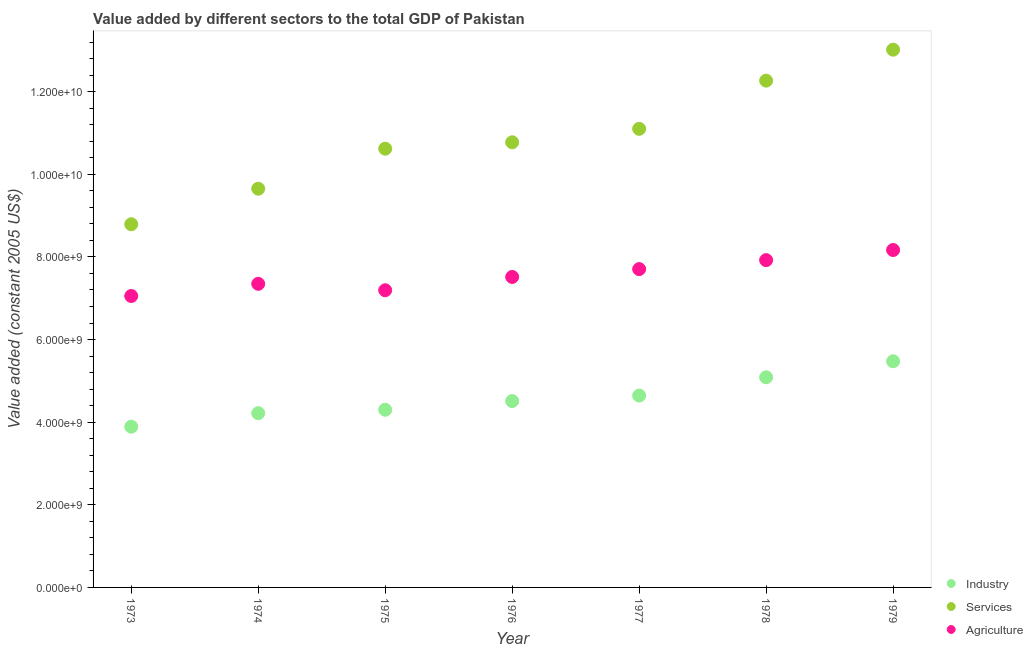What is the value added by industrial sector in 1978?
Make the answer very short. 5.09e+09. Across all years, what is the maximum value added by services?
Offer a terse response. 1.30e+1. Across all years, what is the minimum value added by agricultural sector?
Keep it short and to the point. 7.05e+09. In which year was the value added by agricultural sector maximum?
Provide a short and direct response. 1979. In which year was the value added by services minimum?
Offer a very short reply. 1973. What is the total value added by industrial sector in the graph?
Your answer should be compact. 3.21e+1. What is the difference between the value added by services in 1978 and that in 1979?
Your response must be concise. -7.49e+08. What is the difference between the value added by agricultural sector in 1975 and the value added by services in 1976?
Give a very brief answer. -3.58e+09. What is the average value added by agricultural sector per year?
Keep it short and to the point. 7.56e+09. In the year 1973, what is the difference between the value added by industrial sector and value added by services?
Offer a terse response. -4.90e+09. In how many years, is the value added by agricultural sector greater than 10000000000 US$?
Make the answer very short. 0. What is the ratio of the value added by industrial sector in 1974 to that in 1978?
Offer a very short reply. 0.83. Is the value added by agricultural sector in 1973 less than that in 1975?
Give a very brief answer. Yes. Is the difference between the value added by services in 1973 and 1975 greater than the difference between the value added by industrial sector in 1973 and 1975?
Provide a succinct answer. No. What is the difference between the highest and the second highest value added by services?
Your answer should be very brief. 7.49e+08. What is the difference between the highest and the lowest value added by agricultural sector?
Your response must be concise. 1.11e+09. In how many years, is the value added by services greater than the average value added by services taken over all years?
Your response must be concise. 3. Does the value added by services monotonically increase over the years?
Offer a terse response. Yes. Is the value added by services strictly less than the value added by industrial sector over the years?
Make the answer very short. No. How many dotlines are there?
Ensure brevity in your answer.  3. Does the graph contain any zero values?
Give a very brief answer. No. Does the graph contain grids?
Provide a short and direct response. No. What is the title of the graph?
Your answer should be compact. Value added by different sectors to the total GDP of Pakistan. What is the label or title of the Y-axis?
Your answer should be compact. Value added (constant 2005 US$). What is the Value added (constant 2005 US$) in Industry in 1973?
Your answer should be very brief. 3.89e+09. What is the Value added (constant 2005 US$) in Services in 1973?
Your answer should be compact. 8.79e+09. What is the Value added (constant 2005 US$) in Agriculture in 1973?
Your answer should be very brief. 7.05e+09. What is the Value added (constant 2005 US$) of Industry in 1974?
Your answer should be very brief. 4.22e+09. What is the Value added (constant 2005 US$) in Services in 1974?
Your response must be concise. 9.65e+09. What is the Value added (constant 2005 US$) in Agriculture in 1974?
Ensure brevity in your answer.  7.35e+09. What is the Value added (constant 2005 US$) of Industry in 1975?
Offer a very short reply. 4.30e+09. What is the Value added (constant 2005 US$) in Services in 1975?
Your response must be concise. 1.06e+1. What is the Value added (constant 2005 US$) of Agriculture in 1975?
Offer a very short reply. 7.19e+09. What is the Value added (constant 2005 US$) of Industry in 1976?
Give a very brief answer. 4.51e+09. What is the Value added (constant 2005 US$) in Services in 1976?
Give a very brief answer. 1.08e+1. What is the Value added (constant 2005 US$) of Agriculture in 1976?
Offer a very short reply. 7.52e+09. What is the Value added (constant 2005 US$) in Industry in 1977?
Your answer should be very brief. 4.64e+09. What is the Value added (constant 2005 US$) of Services in 1977?
Your response must be concise. 1.11e+1. What is the Value added (constant 2005 US$) in Agriculture in 1977?
Offer a very short reply. 7.71e+09. What is the Value added (constant 2005 US$) in Industry in 1978?
Your answer should be compact. 5.09e+09. What is the Value added (constant 2005 US$) in Services in 1978?
Keep it short and to the point. 1.23e+1. What is the Value added (constant 2005 US$) in Agriculture in 1978?
Your answer should be very brief. 7.92e+09. What is the Value added (constant 2005 US$) of Industry in 1979?
Give a very brief answer. 5.47e+09. What is the Value added (constant 2005 US$) of Services in 1979?
Provide a succinct answer. 1.30e+1. What is the Value added (constant 2005 US$) of Agriculture in 1979?
Your answer should be very brief. 8.17e+09. Across all years, what is the maximum Value added (constant 2005 US$) in Industry?
Your answer should be very brief. 5.47e+09. Across all years, what is the maximum Value added (constant 2005 US$) of Services?
Make the answer very short. 1.30e+1. Across all years, what is the maximum Value added (constant 2005 US$) of Agriculture?
Offer a very short reply. 8.17e+09. Across all years, what is the minimum Value added (constant 2005 US$) in Industry?
Ensure brevity in your answer.  3.89e+09. Across all years, what is the minimum Value added (constant 2005 US$) of Services?
Your answer should be compact. 8.79e+09. Across all years, what is the minimum Value added (constant 2005 US$) in Agriculture?
Keep it short and to the point. 7.05e+09. What is the total Value added (constant 2005 US$) in Industry in the graph?
Give a very brief answer. 3.21e+1. What is the total Value added (constant 2005 US$) in Services in the graph?
Provide a succinct answer. 7.62e+1. What is the total Value added (constant 2005 US$) of Agriculture in the graph?
Your answer should be very brief. 5.29e+1. What is the difference between the Value added (constant 2005 US$) of Industry in 1973 and that in 1974?
Your answer should be compact. -3.27e+08. What is the difference between the Value added (constant 2005 US$) of Services in 1973 and that in 1974?
Your answer should be very brief. -8.61e+08. What is the difference between the Value added (constant 2005 US$) in Agriculture in 1973 and that in 1974?
Your answer should be compact. -2.95e+08. What is the difference between the Value added (constant 2005 US$) in Industry in 1973 and that in 1975?
Provide a succinct answer. -4.10e+08. What is the difference between the Value added (constant 2005 US$) in Services in 1973 and that in 1975?
Your response must be concise. -1.83e+09. What is the difference between the Value added (constant 2005 US$) of Agriculture in 1973 and that in 1975?
Your answer should be very brief. -1.39e+08. What is the difference between the Value added (constant 2005 US$) of Industry in 1973 and that in 1976?
Your answer should be compact. -6.21e+08. What is the difference between the Value added (constant 2005 US$) of Services in 1973 and that in 1976?
Make the answer very short. -1.98e+09. What is the difference between the Value added (constant 2005 US$) of Agriculture in 1973 and that in 1976?
Your response must be concise. -4.61e+08. What is the difference between the Value added (constant 2005 US$) in Industry in 1973 and that in 1977?
Your answer should be compact. -7.54e+08. What is the difference between the Value added (constant 2005 US$) of Services in 1973 and that in 1977?
Provide a succinct answer. -2.31e+09. What is the difference between the Value added (constant 2005 US$) of Agriculture in 1973 and that in 1977?
Ensure brevity in your answer.  -6.51e+08. What is the difference between the Value added (constant 2005 US$) in Industry in 1973 and that in 1978?
Your answer should be compact. -1.20e+09. What is the difference between the Value added (constant 2005 US$) in Services in 1973 and that in 1978?
Ensure brevity in your answer.  -3.48e+09. What is the difference between the Value added (constant 2005 US$) of Agriculture in 1973 and that in 1978?
Make the answer very short. -8.68e+08. What is the difference between the Value added (constant 2005 US$) in Industry in 1973 and that in 1979?
Offer a terse response. -1.58e+09. What is the difference between the Value added (constant 2005 US$) in Services in 1973 and that in 1979?
Your answer should be compact. -4.23e+09. What is the difference between the Value added (constant 2005 US$) in Agriculture in 1973 and that in 1979?
Provide a succinct answer. -1.11e+09. What is the difference between the Value added (constant 2005 US$) in Industry in 1974 and that in 1975?
Offer a terse response. -8.25e+07. What is the difference between the Value added (constant 2005 US$) of Services in 1974 and that in 1975?
Give a very brief answer. -9.69e+08. What is the difference between the Value added (constant 2005 US$) in Agriculture in 1974 and that in 1975?
Your answer should be very brief. 1.56e+08. What is the difference between the Value added (constant 2005 US$) of Industry in 1974 and that in 1976?
Your answer should be compact. -2.93e+08. What is the difference between the Value added (constant 2005 US$) of Services in 1974 and that in 1976?
Give a very brief answer. -1.12e+09. What is the difference between the Value added (constant 2005 US$) of Agriculture in 1974 and that in 1976?
Your answer should be very brief. -1.66e+08. What is the difference between the Value added (constant 2005 US$) of Industry in 1974 and that in 1977?
Your answer should be compact. -4.26e+08. What is the difference between the Value added (constant 2005 US$) of Services in 1974 and that in 1977?
Ensure brevity in your answer.  -1.45e+09. What is the difference between the Value added (constant 2005 US$) in Agriculture in 1974 and that in 1977?
Give a very brief answer. -3.56e+08. What is the difference between the Value added (constant 2005 US$) of Industry in 1974 and that in 1978?
Make the answer very short. -8.68e+08. What is the difference between the Value added (constant 2005 US$) of Services in 1974 and that in 1978?
Offer a terse response. -2.62e+09. What is the difference between the Value added (constant 2005 US$) of Agriculture in 1974 and that in 1978?
Your answer should be very brief. -5.73e+08. What is the difference between the Value added (constant 2005 US$) in Industry in 1974 and that in 1979?
Keep it short and to the point. -1.26e+09. What is the difference between the Value added (constant 2005 US$) of Services in 1974 and that in 1979?
Ensure brevity in your answer.  -3.37e+09. What is the difference between the Value added (constant 2005 US$) of Agriculture in 1974 and that in 1979?
Provide a succinct answer. -8.19e+08. What is the difference between the Value added (constant 2005 US$) in Industry in 1975 and that in 1976?
Provide a succinct answer. -2.11e+08. What is the difference between the Value added (constant 2005 US$) in Services in 1975 and that in 1976?
Make the answer very short. -1.54e+08. What is the difference between the Value added (constant 2005 US$) in Agriculture in 1975 and that in 1976?
Offer a terse response. -3.22e+08. What is the difference between the Value added (constant 2005 US$) of Industry in 1975 and that in 1977?
Make the answer very short. -3.44e+08. What is the difference between the Value added (constant 2005 US$) in Services in 1975 and that in 1977?
Offer a terse response. -4.81e+08. What is the difference between the Value added (constant 2005 US$) of Agriculture in 1975 and that in 1977?
Keep it short and to the point. -5.12e+08. What is the difference between the Value added (constant 2005 US$) in Industry in 1975 and that in 1978?
Provide a short and direct response. -7.86e+08. What is the difference between the Value added (constant 2005 US$) in Services in 1975 and that in 1978?
Your response must be concise. -1.65e+09. What is the difference between the Value added (constant 2005 US$) in Agriculture in 1975 and that in 1978?
Provide a short and direct response. -7.29e+08. What is the difference between the Value added (constant 2005 US$) of Industry in 1975 and that in 1979?
Your answer should be very brief. -1.17e+09. What is the difference between the Value added (constant 2005 US$) of Services in 1975 and that in 1979?
Your response must be concise. -2.40e+09. What is the difference between the Value added (constant 2005 US$) in Agriculture in 1975 and that in 1979?
Ensure brevity in your answer.  -9.74e+08. What is the difference between the Value added (constant 2005 US$) in Industry in 1976 and that in 1977?
Give a very brief answer. -1.33e+08. What is the difference between the Value added (constant 2005 US$) in Services in 1976 and that in 1977?
Offer a terse response. -3.26e+08. What is the difference between the Value added (constant 2005 US$) in Agriculture in 1976 and that in 1977?
Your response must be concise. -1.90e+08. What is the difference between the Value added (constant 2005 US$) of Industry in 1976 and that in 1978?
Give a very brief answer. -5.75e+08. What is the difference between the Value added (constant 2005 US$) of Services in 1976 and that in 1978?
Ensure brevity in your answer.  -1.49e+09. What is the difference between the Value added (constant 2005 US$) in Agriculture in 1976 and that in 1978?
Make the answer very short. -4.07e+08. What is the difference between the Value added (constant 2005 US$) of Industry in 1976 and that in 1979?
Give a very brief answer. -9.63e+08. What is the difference between the Value added (constant 2005 US$) of Services in 1976 and that in 1979?
Ensure brevity in your answer.  -2.24e+09. What is the difference between the Value added (constant 2005 US$) in Agriculture in 1976 and that in 1979?
Make the answer very short. -6.53e+08. What is the difference between the Value added (constant 2005 US$) of Industry in 1977 and that in 1978?
Offer a very short reply. -4.42e+08. What is the difference between the Value added (constant 2005 US$) of Services in 1977 and that in 1978?
Ensure brevity in your answer.  -1.17e+09. What is the difference between the Value added (constant 2005 US$) in Agriculture in 1977 and that in 1978?
Provide a succinct answer. -2.17e+08. What is the difference between the Value added (constant 2005 US$) in Industry in 1977 and that in 1979?
Your response must be concise. -8.30e+08. What is the difference between the Value added (constant 2005 US$) of Services in 1977 and that in 1979?
Provide a succinct answer. -1.92e+09. What is the difference between the Value added (constant 2005 US$) in Agriculture in 1977 and that in 1979?
Offer a very short reply. -4.63e+08. What is the difference between the Value added (constant 2005 US$) of Industry in 1978 and that in 1979?
Ensure brevity in your answer.  -3.88e+08. What is the difference between the Value added (constant 2005 US$) in Services in 1978 and that in 1979?
Offer a very short reply. -7.49e+08. What is the difference between the Value added (constant 2005 US$) of Agriculture in 1978 and that in 1979?
Offer a terse response. -2.45e+08. What is the difference between the Value added (constant 2005 US$) in Industry in 1973 and the Value added (constant 2005 US$) in Services in 1974?
Give a very brief answer. -5.76e+09. What is the difference between the Value added (constant 2005 US$) in Industry in 1973 and the Value added (constant 2005 US$) in Agriculture in 1974?
Make the answer very short. -3.46e+09. What is the difference between the Value added (constant 2005 US$) of Services in 1973 and the Value added (constant 2005 US$) of Agriculture in 1974?
Provide a short and direct response. 1.44e+09. What is the difference between the Value added (constant 2005 US$) of Industry in 1973 and the Value added (constant 2005 US$) of Services in 1975?
Make the answer very short. -6.73e+09. What is the difference between the Value added (constant 2005 US$) of Industry in 1973 and the Value added (constant 2005 US$) of Agriculture in 1975?
Your answer should be compact. -3.30e+09. What is the difference between the Value added (constant 2005 US$) of Services in 1973 and the Value added (constant 2005 US$) of Agriculture in 1975?
Make the answer very short. 1.60e+09. What is the difference between the Value added (constant 2005 US$) of Industry in 1973 and the Value added (constant 2005 US$) of Services in 1976?
Keep it short and to the point. -6.88e+09. What is the difference between the Value added (constant 2005 US$) in Industry in 1973 and the Value added (constant 2005 US$) in Agriculture in 1976?
Offer a very short reply. -3.62e+09. What is the difference between the Value added (constant 2005 US$) in Services in 1973 and the Value added (constant 2005 US$) in Agriculture in 1976?
Provide a succinct answer. 1.28e+09. What is the difference between the Value added (constant 2005 US$) of Industry in 1973 and the Value added (constant 2005 US$) of Services in 1977?
Provide a short and direct response. -7.21e+09. What is the difference between the Value added (constant 2005 US$) in Industry in 1973 and the Value added (constant 2005 US$) in Agriculture in 1977?
Provide a succinct answer. -3.81e+09. What is the difference between the Value added (constant 2005 US$) in Services in 1973 and the Value added (constant 2005 US$) in Agriculture in 1977?
Your answer should be very brief. 1.09e+09. What is the difference between the Value added (constant 2005 US$) of Industry in 1973 and the Value added (constant 2005 US$) of Services in 1978?
Provide a succinct answer. -8.38e+09. What is the difference between the Value added (constant 2005 US$) of Industry in 1973 and the Value added (constant 2005 US$) of Agriculture in 1978?
Offer a terse response. -4.03e+09. What is the difference between the Value added (constant 2005 US$) in Services in 1973 and the Value added (constant 2005 US$) in Agriculture in 1978?
Your response must be concise. 8.68e+08. What is the difference between the Value added (constant 2005 US$) of Industry in 1973 and the Value added (constant 2005 US$) of Services in 1979?
Make the answer very short. -9.13e+09. What is the difference between the Value added (constant 2005 US$) in Industry in 1973 and the Value added (constant 2005 US$) in Agriculture in 1979?
Your response must be concise. -4.28e+09. What is the difference between the Value added (constant 2005 US$) of Services in 1973 and the Value added (constant 2005 US$) of Agriculture in 1979?
Offer a terse response. 6.23e+08. What is the difference between the Value added (constant 2005 US$) in Industry in 1974 and the Value added (constant 2005 US$) in Services in 1975?
Your response must be concise. -6.40e+09. What is the difference between the Value added (constant 2005 US$) of Industry in 1974 and the Value added (constant 2005 US$) of Agriculture in 1975?
Provide a succinct answer. -2.98e+09. What is the difference between the Value added (constant 2005 US$) of Services in 1974 and the Value added (constant 2005 US$) of Agriculture in 1975?
Make the answer very short. 2.46e+09. What is the difference between the Value added (constant 2005 US$) of Industry in 1974 and the Value added (constant 2005 US$) of Services in 1976?
Offer a very short reply. -6.56e+09. What is the difference between the Value added (constant 2005 US$) in Industry in 1974 and the Value added (constant 2005 US$) in Agriculture in 1976?
Provide a short and direct response. -3.30e+09. What is the difference between the Value added (constant 2005 US$) of Services in 1974 and the Value added (constant 2005 US$) of Agriculture in 1976?
Provide a succinct answer. 2.14e+09. What is the difference between the Value added (constant 2005 US$) in Industry in 1974 and the Value added (constant 2005 US$) in Services in 1977?
Keep it short and to the point. -6.88e+09. What is the difference between the Value added (constant 2005 US$) in Industry in 1974 and the Value added (constant 2005 US$) in Agriculture in 1977?
Give a very brief answer. -3.49e+09. What is the difference between the Value added (constant 2005 US$) of Services in 1974 and the Value added (constant 2005 US$) of Agriculture in 1977?
Ensure brevity in your answer.  1.95e+09. What is the difference between the Value added (constant 2005 US$) of Industry in 1974 and the Value added (constant 2005 US$) of Services in 1978?
Keep it short and to the point. -8.05e+09. What is the difference between the Value added (constant 2005 US$) in Industry in 1974 and the Value added (constant 2005 US$) in Agriculture in 1978?
Provide a succinct answer. -3.70e+09. What is the difference between the Value added (constant 2005 US$) in Services in 1974 and the Value added (constant 2005 US$) in Agriculture in 1978?
Your response must be concise. 1.73e+09. What is the difference between the Value added (constant 2005 US$) in Industry in 1974 and the Value added (constant 2005 US$) in Services in 1979?
Give a very brief answer. -8.80e+09. What is the difference between the Value added (constant 2005 US$) in Industry in 1974 and the Value added (constant 2005 US$) in Agriculture in 1979?
Provide a short and direct response. -3.95e+09. What is the difference between the Value added (constant 2005 US$) of Services in 1974 and the Value added (constant 2005 US$) of Agriculture in 1979?
Make the answer very short. 1.48e+09. What is the difference between the Value added (constant 2005 US$) in Industry in 1975 and the Value added (constant 2005 US$) in Services in 1976?
Offer a terse response. -6.47e+09. What is the difference between the Value added (constant 2005 US$) in Industry in 1975 and the Value added (constant 2005 US$) in Agriculture in 1976?
Your answer should be very brief. -3.21e+09. What is the difference between the Value added (constant 2005 US$) of Services in 1975 and the Value added (constant 2005 US$) of Agriculture in 1976?
Your answer should be compact. 3.11e+09. What is the difference between the Value added (constant 2005 US$) in Industry in 1975 and the Value added (constant 2005 US$) in Services in 1977?
Keep it short and to the point. -6.80e+09. What is the difference between the Value added (constant 2005 US$) of Industry in 1975 and the Value added (constant 2005 US$) of Agriculture in 1977?
Provide a succinct answer. -3.40e+09. What is the difference between the Value added (constant 2005 US$) in Services in 1975 and the Value added (constant 2005 US$) in Agriculture in 1977?
Provide a short and direct response. 2.92e+09. What is the difference between the Value added (constant 2005 US$) of Industry in 1975 and the Value added (constant 2005 US$) of Services in 1978?
Your response must be concise. -7.97e+09. What is the difference between the Value added (constant 2005 US$) in Industry in 1975 and the Value added (constant 2005 US$) in Agriculture in 1978?
Your answer should be compact. -3.62e+09. What is the difference between the Value added (constant 2005 US$) in Services in 1975 and the Value added (constant 2005 US$) in Agriculture in 1978?
Your response must be concise. 2.70e+09. What is the difference between the Value added (constant 2005 US$) of Industry in 1975 and the Value added (constant 2005 US$) of Services in 1979?
Give a very brief answer. -8.72e+09. What is the difference between the Value added (constant 2005 US$) of Industry in 1975 and the Value added (constant 2005 US$) of Agriculture in 1979?
Provide a succinct answer. -3.87e+09. What is the difference between the Value added (constant 2005 US$) in Services in 1975 and the Value added (constant 2005 US$) in Agriculture in 1979?
Ensure brevity in your answer.  2.45e+09. What is the difference between the Value added (constant 2005 US$) in Industry in 1976 and the Value added (constant 2005 US$) in Services in 1977?
Your answer should be compact. -6.59e+09. What is the difference between the Value added (constant 2005 US$) in Industry in 1976 and the Value added (constant 2005 US$) in Agriculture in 1977?
Provide a short and direct response. -3.19e+09. What is the difference between the Value added (constant 2005 US$) in Services in 1976 and the Value added (constant 2005 US$) in Agriculture in 1977?
Your answer should be very brief. 3.07e+09. What is the difference between the Value added (constant 2005 US$) of Industry in 1976 and the Value added (constant 2005 US$) of Services in 1978?
Make the answer very short. -7.76e+09. What is the difference between the Value added (constant 2005 US$) in Industry in 1976 and the Value added (constant 2005 US$) in Agriculture in 1978?
Give a very brief answer. -3.41e+09. What is the difference between the Value added (constant 2005 US$) of Services in 1976 and the Value added (constant 2005 US$) of Agriculture in 1978?
Offer a very short reply. 2.85e+09. What is the difference between the Value added (constant 2005 US$) in Industry in 1976 and the Value added (constant 2005 US$) in Services in 1979?
Give a very brief answer. -8.51e+09. What is the difference between the Value added (constant 2005 US$) of Industry in 1976 and the Value added (constant 2005 US$) of Agriculture in 1979?
Provide a short and direct response. -3.66e+09. What is the difference between the Value added (constant 2005 US$) in Services in 1976 and the Value added (constant 2005 US$) in Agriculture in 1979?
Your answer should be very brief. 2.61e+09. What is the difference between the Value added (constant 2005 US$) of Industry in 1977 and the Value added (constant 2005 US$) of Services in 1978?
Your answer should be very brief. -7.62e+09. What is the difference between the Value added (constant 2005 US$) of Industry in 1977 and the Value added (constant 2005 US$) of Agriculture in 1978?
Offer a very short reply. -3.28e+09. What is the difference between the Value added (constant 2005 US$) in Services in 1977 and the Value added (constant 2005 US$) in Agriculture in 1978?
Keep it short and to the point. 3.18e+09. What is the difference between the Value added (constant 2005 US$) in Industry in 1977 and the Value added (constant 2005 US$) in Services in 1979?
Give a very brief answer. -8.37e+09. What is the difference between the Value added (constant 2005 US$) in Industry in 1977 and the Value added (constant 2005 US$) in Agriculture in 1979?
Your response must be concise. -3.52e+09. What is the difference between the Value added (constant 2005 US$) in Services in 1977 and the Value added (constant 2005 US$) in Agriculture in 1979?
Provide a short and direct response. 2.93e+09. What is the difference between the Value added (constant 2005 US$) in Industry in 1978 and the Value added (constant 2005 US$) in Services in 1979?
Ensure brevity in your answer.  -7.93e+09. What is the difference between the Value added (constant 2005 US$) in Industry in 1978 and the Value added (constant 2005 US$) in Agriculture in 1979?
Give a very brief answer. -3.08e+09. What is the difference between the Value added (constant 2005 US$) of Services in 1978 and the Value added (constant 2005 US$) of Agriculture in 1979?
Your answer should be compact. 4.10e+09. What is the average Value added (constant 2005 US$) of Industry per year?
Give a very brief answer. 4.59e+09. What is the average Value added (constant 2005 US$) in Services per year?
Give a very brief answer. 1.09e+1. What is the average Value added (constant 2005 US$) of Agriculture per year?
Provide a succinct answer. 7.56e+09. In the year 1973, what is the difference between the Value added (constant 2005 US$) in Industry and Value added (constant 2005 US$) in Services?
Make the answer very short. -4.90e+09. In the year 1973, what is the difference between the Value added (constant 2005 US$) in Industry and Value added (constant 2005 US$) in Agriculture?
Give a very brief answer. -3.16e+09. In the year 1973, what is the difference between the Value added (constant 2005 US$) in Services and Value added (constant 2005 US$) in Agriculture?
Make the answer very short. 1.74e+09. In the year 1974, what is the difference between the Value added (constant 2005 US$) in Industry and Value added (constant 2005 US$) in Services?
Ensure brevity in your answer.  -5.43e+09. In the year 1974, what is the difference between the Value added (constant 2005 US$) in Industry and Value added (constant 2005 US$) in Agriculture?
Offer a terse response. -3.13e+09. In the year 1974, what is the difference between the Value added (constant 2005 US$) of Services and Value added (constant 2005 US$) of Agriculture?
Your answer should be compact. 2.30e+09. In the year 1975, what is the difference between the Value added (constant 2005 US$) in Industry and Value added (constant 2005 US$) in Services?
Make the answer very short. -6.32e+09. In the year 1975, what is the difference between the Value added (constant 2005 US$) of Industry and Value added (constant 2005 US$) of Agriculture?
Offer a very short reply. -2.89e+09. In the year 1975, what is the difference between the Value added (constant 2005 US$) of Services and Value added (constant 2005 US$) of Agriculture?
Your answer should be compact. 3.43e+09. In the year 1976, what is the difference between the Value added (constant 2005 US$) of Industry and Value added (constant 2005 US$) of Services?
Your response must be concise. -6.26e+09. In the year 1976, what is the difference between the Value added (constant 2005 US$) in Industry and Value added (constant 2005 US$) in Agriculture?
Make the answer very short. -3.00e+09. In the year 1976, what is the difference between the Value added (constant 2005 US$) of Services and Value added (constant 2005 US$) of Agriculture?
Offer a very short reply. 3.26e+09. In the year 1977, what is the difference between the Value added (constant 2005 US$) in Industry and Value added (constant 2005 US$) in Services?
Your response must be concise. -6.46e+09. In the year 1977, what is the difference between the Value added (constant 2005 US$) of Industry and Value added (constant 2005 US$) of Agriculture?
Keep it short and to the point. -3.06e+09. In the year 1977, what is the difference between the Value added (constant 2005 US$) of Services and Value added (constant 2005 US$) of Agriculture?
Ensure brevity in your answer.  3.40e+09. In the year 1978, what is the difference between the Value added (constant 2005 US$) of Industry and Value added (constant 2005 US$) of Services?
Provide a short and direct response. -7.18e+09. In the year 1978, what is the difference between the Value added (constant 2005 US$) in Industry and Value added (constant 2005 US$) in Agriculture?
Provide a succinct answer. -2.84e+09. In the year 1978, what is the difference between the Value added (constant 2005 US$) in Services and Value added (constant 2005 US$) in Agriculture?
Provide a short and direct response. 4.35e+09. In the year 1979, what is the difference between the Value added (constant 2005 US$) of Industry and Value added (constant 2005 US$) of Services?
Offer a very short reply. -7.54e+09. In the year 1979, what is the difference between the Value added (constant 2005 US$) in Industry and Value added (constant 2005 US$) in Agriculture?
Your answer should be very brief. -2.69e+09. In the year 1979, what is the difference between the Value added (constant 2005 US$) of Services and Value added (constant 2005 US$) of Agriculture?
Give a very brief answer. 4.85e+09. What is the ratio of the Value added (constant 2005 US$) in Industry in 1973 to that in 1974?
Make the answer very short. 0.92. What is the ratio of the Value added (constant 2005 US$) in Services in 1973 to that in 1974?
Your answer should be very brief. 0.91. What is the ratio of the Value added (constant 2005 US$) of Agriculture in 1973 to that in 1974?
Offer a very short reply. 0.96. What is the ratio of the Value added (constant 2005 US$) in Industry in 1973 to that in 1975?
Your answer should be very brief. 0.9. What is the ratio of the Value added (constant 2005 US$) in Services in 1973 to that in 1975?
Your response must be concise. 0.83. What is the ratio of the Value added (constant 2005 US$) in Agriculture in 1973 to that in 1975?
Keep it short and to the point. 0.98. What is the ratio of the Value added (constant 2005 US$) of Industry in 1973 to that in 1976?
Ensure brevity in your answer.  0.86. What is the ratio of the Value added (constant 2005 US$) of Services in 1973 to that in 1976?
Offer a terse response. 0.82. What is the ratio of the Value added (constant 2005 US$) in Agriculture in 1973 to that in 1976?
Your response must be concise. 0.94. What is the ratio of the Value added (constant 2005 US$) in Industry in 1973 to that in 1977?
Your answer should be compact. 0.84. What is the ratio of the Value added (constant 2005 US$) of Services in 1973 to that in 1977?
Give a very brief answer. 0.79. What is the ratio of the Value added (constant 2005 US$) of Agriculture in 1973 to that in 1977?
Offer a very short reply. 0.92. What is the ratio of the Value added (constant 2005 US$) in Industry in 1973 to that in 1978?
Your answer should be very brief. 0.77. What is the ratio of the Value added (constant 2005 US$) of Services in 1973 to that in 1978?
Keep it short and to the point. 0.72. What is the ratio of the Value added (constant 2005 US$) in Agriculture in 1973 to that in 1978?
Provide a succinct answer. 0.89. What is the ratio of the Value added (constant 2005 US$) in Industry in 1973 to that in 1979?
Give a very brief answer. 0.71. What is the ratio of the Value added (constant 2005 US$) of Services in 1973 to that in 1979?
Make the answer very short. 0.68. What is the ratio of the Value added (constant 2005 US$) in Agriculture in 1973 to that in 1979?
Provide a succinct answer. 0.86. What is the ratio of the Value added (constant 2005 US$) of Industry in 1974 to that in 1975?
Offer a very short reply. 0.98. What is the ratio of the Value added (constant 2005 US$) in Services in 1974 to that in 1975?
Give a very brief answer. 0.91. What is the ratio of the Value added (constant 2005 US$) of Agriculture in 1974 to that in 1975?
Ensure brevity in your answer.  1.02. What is the ratio of the Value added (constant 2005 US$) of Industry in 1974 to that in 1976?
Provide a succinct answer. 0.94. What is the ratio of the Value added (constant 2005 US$) in Services in 1974 to that in 1976?
Ensure brevity in your answer.  0.9. What is the ratio of the Value added (constant 2005 US$) in Agriculture in 1974 to that in 1976?
Your answer should be compact. 0.98. What is the ratio of the Value added (constant 2005 US$) in Industry in 1974 to that in 1977?
Offer a very short reply. 0.91. What is the ratio of the Value added (constant 2005 US$) in Services in 1974 to that in 1977?
Your response must be concise. 0.87. What is the ratio of the Value added (constant 2005 US$) of Agriculture in 1974 to that in 1977?
Offer a terse response. 0.95. What is the ratio of the Value added (constant 2005 US$) of Industry in 1974 to that in 1978?
Offer a very short reply. 0.83. What is the ratio of the Value added (constant 2005 US$) in Services in 1974 to that in 1978?
Offer a very short reply. 0.79. What is the ratio of the Value added (constant 2005 US$) in Agriculture in 1974 to that in 1978?
Provide a short and direct response. 0.93. What is the ratio of the Value added (constant 2005 US$) in Industry in 1974 to that in 1979?
Keep it short and to the point. 0.77. What is the ratio of the Value added (constant 2005 US$) of Services in 1974 to that in 1979?
Offer a terse response. 0.74. What is the ratio of the Value added (constant 2005 US$) of Agriculture in 1974 to that in 1979?
Offer a terse response. 0.9. What is the ratio of the Value added (constant 2005 US$) of Industry in 1975 to that in 1976?
Keep it short and to the point. 0.95. What is the ratio of the Value added (constant 2005 US$) in Services in 1975 to that in 1976?
Your answer should be compact. 0.99. What is the ratio of the Value added (constant 2005 US$) in Agriculture in 1975 to that in 1976?
Keep it short and to the point. 0.96. What is the ratio of the Value added (constant 2005 US$) of Industry in 1975 to that in 1977?
Your answer should be very brief. 0.93. What is the ratio of the Value added (constant 2005 US$) in Services in 1975 to that in 1977?
Make the answer very short. 0.96. What is the ratio of the Value added (constant 2005 US$) of Agriculture in 1975 to that in 1977?
Give a very brief answer. 0.93. What is the ratio of the Value added (constant 2005 US$) of Industry in 1975 to that in 1978?
Your response must be concise. 0.85. What is the ratio of the Value added (constant 2005 US$) in Services in 1975 to that in 1978?
Offer a terse response. 0.87. What is the ratio of the Value added (constant 2005 US$) of Agriculture in 1975 to that in 1978?
Offer a terse response. 0.91. What is the ratio of the Value added (constant 2005 US$) of Industry in 1975 to that in 1979?
Provide a succinct answer. 0.79. What is the ratio of the Value added (constant 2005 US$) in Services in 1975 to that in 1979?
Provide a short and direct response. 0.82. What is the ratio of the Value added (constant 2005 US$) of Agriculture in 1975 to that in 1979?
Your answer should be very brief. 0.88. What is the ratio of the Value added (constant 2005 US$) in Industry in 1976 to that in 1977?
Give a very brief answer. 0.97. What is the ratio of the Value added (constant 2005 US$) of Services in 1976 to that in 1977?
Offer a terse response. 0.97. What is the ratio of the Value added (constant 2005 US$) in Agriculture in 1976 to that in 1977?
Make the answer very short. 0.98. What is the ratio of the Value added (constant 2005 US$) of Industry in 1976 to that in 1978?
Offer a very short reply. 0.89. What is the ratio of the Value added (constant 2005 US$) in Services in 1976 to that in 1978?
Your answer should be very brief. 0.88. What is the ratio of the Value added (constant 2005 US$) of Agriculture in 1976 to that in 1978?
Provide a short and direct response. 0.95. What is the ratio of the Value added (constant 2005 US$) in Industry in 1976 to that in 1979?
Make the answer very short. 0.82. What is the ratio of the Value added (constant 2005 US$) of Services in 1976 to that in 1979?
Your answer should be very brief. 0.83. What is the ratio of the Value added (constant 2005 US$) in Agriculture in 1976 to that in 1979?
Make the answer very short. 0.92. What is the ratio of the Value added (constant 2005 US$) of Industry in 1977 to that in 1978?
Make the answer very short. 0.91. What is the ratio of the Value added (constant 2005 US$) in Services in 1977 to that in 1978?
Give a very brief answer. 0.9. What is the ratio of the Value added (constant 2005 US$) of Agriculture in 1977 to that in 1978?
Keep it short and to the point. 0.97. What is the ratio of the Value added (constant 2005 US$) in Industry in 1977 to that in 1979?
Keep it short and to the point. 0.85. What is the ratio of the Value added (constant 2005 US$) in Services in 1977 to that in 1979?
Your answer should be very brief. 0.85. What is the ratio of the Value added (constant 2005 US$) in Agriculture in 1977 to that in 1979?
Offer a very short reply. 0.94. What is the ratio of the Value added (constant 2005 US$) of Industry in 1978 to that in 1979?
Offer a terse response. 0.93. What is the ratio of the Value added (constant 2005 US$) in Services in 1978 to that in 1979?
Your response must be concise. 0.94. What is the difference between the highest and the second highest Value added (constant 2005 US$) of Industry?
Make the answer very short. 3.88e+08. What is the difference between the highest and the second highest Value added (constant 2005 US$) in Services?
Make the answer very short. 7.49e+08. What is the difference between the highest and the second highest Value added (constant 2005 US$) of Agriculture?
Keep it short and to the point. 2.45e+08. What is the difference between the highest and the lowest Value added (constant 2005 US$) in Industry?
Your answer should be compact. 1.58e+09. What is the difference between the highest and the lowest Value added (constant 2005 US$) in Services?
Ensure brevity in your answer.  4.23e+09. What is the difference between the highest and the lowest Value added (constant 2005 US$) of Agriculture?
Your answer should be compact. 1.11e+09. 